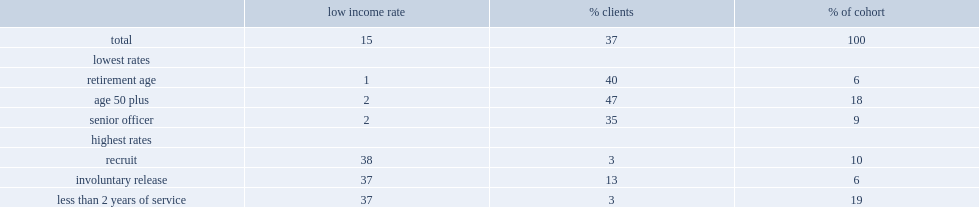What is the rates of veterans who were released as recruits had experiencing low income at least one year post-release? 38.0. What is the rates of veterans who were released as involuntary releases had experiencing low income at least one year post-release? 37.0. What is the rates of veterans who were less than 2 years of service had experiencing low income at least one year post-release? 37.0. What is the rates of veterans who released at retirement age had experiencing low income at least one year post-release? 1.0. What is the rates of veterans who were released at aged 50 and older had experiencing low income at least one year post-release? 2.0. What is the rates of veterans who were released as senior officers had experiencing low income at least one year post-release? 2.0. 